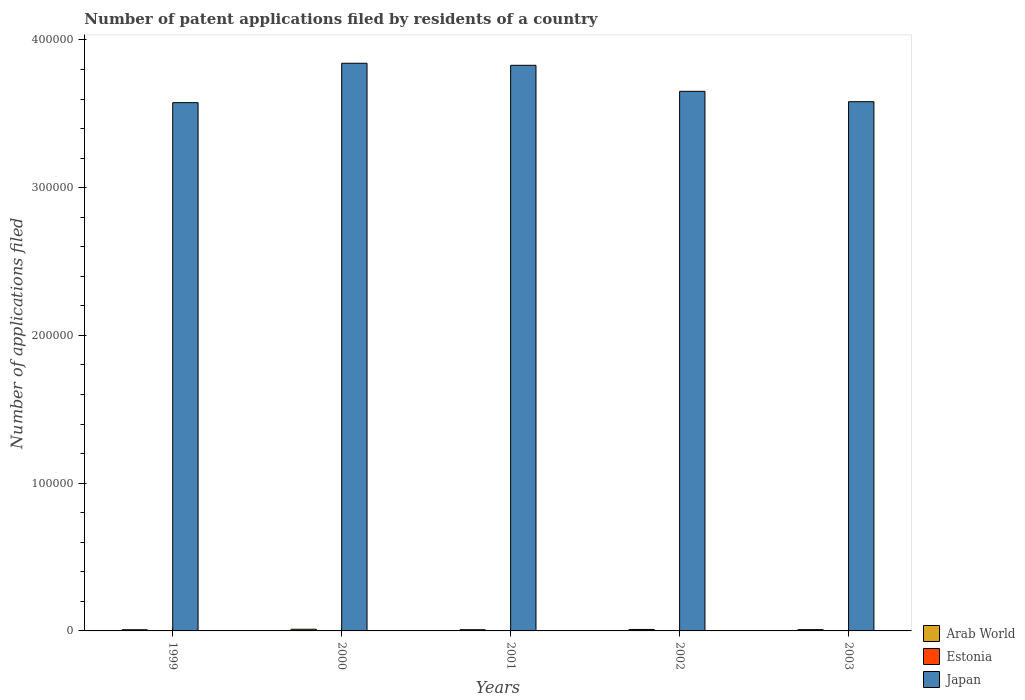How many groups of bars are there?
Your answer should be very brief. 5. Are the number of bars per tick equal to the number of legend labels?
Your response must be concise. Yes. How many bars are there on the 1st tick from the left?
Your answer should be compact. 3. How many bars are there on the 5th tick from the right?
Your answer should be very brief. 3. What is the label of the 1st group of bars from the left?
Your response must be concise. 1999. In how many cases, is the number of bars for a given year not equal to the number of legend labels?
Make the answer very short. 0. What is the number of applications filed in Estonia in 2001?
Provide a succinct answer. 18. Across all years, what is the maximum number of applications filed in Japan?
Your response must be concise. 3.84e+05. In which year was the number of applications filed in Arab World maximum?
Offer a terse response. 2000. In which year was the number of applications filed in Japan minimum?
Keep it short and to the point. 1999. What is the total number of applications filed in Japan in the graph?
Your response must be concise. 1.85e+06. What is the difference between the number of applications filed in Arab World in 1999 and that in 2002?
Provide a short and direct response. -182. What is the difference between the number of applications filed in Arab World in 2002 and the number of applications filed in Estonia in 1999?
Your answer should be compact. 978. What is the average number of applications filed in Japan per year?
Provide a short and direct response. 3.70e+05. In the year 2003, what is the difference between the number of applications filed in Arab World and number of applications filed in Estonia?
Keep it short and to the point. 856. In how many years, is the number of applications filed in Japan greater than 200000?
Offer a very short reply. 5. What is the ratio of the number of applications filed in Estonia in 2000 to that in 2002?
Offer a terse response. 0.68. What is the difference between the highest and the second highest number of applications filed in Japan?
Keep it short and to the point. 1386. What is the difference between the highest and the lowest number of applications filed in Arab World?
Provide a short and direct response. 315. In how many years, is the number of applications filed in Japan greater than the average number of applications filed in Japan taken over all years?
Offer a terse response. 2. Is the sum of the number of applications filed in Arab World in 1999 and 2001 greater than the maximum number of applications filed in Estonia across all years?
Provide a succinct answer. Yes. What does the 1st bar from the left in 2002 represents?
Provide a succinct answer. Arab World. What does the 1st bar from the right in 2000 represents?
Offer a very short reply. Japan. Is it the case that in every year, the sum of the number of applications filed in Estonia and number of applications filed in Arab World is greater than the number of applications filed in Japan?
Make the answer very short. No. Are all the bars in the graph horizontal?
Make the answer very short. No. How many years are there in the graph?
Your response must be concise. 5. Are the values on the major ticks of Y-axis written in scientific E-notation?
Offer a very short reply. No. Does the graph contain any zero values?
Offer a terse response. No. Does the graph contain grids?
Provide a succinct answer. No. Where does the legend appear in the graph?
Offer a terse response. Bottom right. What is the title of the graph?
Offer a terse response. Number of patent applications filed by residents of a country. Does "United States" appear as one of the legend labels in the graph?
Your response must be concise. No. What is the label or title of the X-axis?
Ensure brevity in your answer.  Years. What is the label or title of the Y-axis?
Offer a terse response. Number of applications filed. What is the Number of applications filed in Arab World in 1999?
Offer a very short reply. 809. What is the Number of applications filed in Japan in 1999?
Make the answer very short. 3.58e+05. What is the Number of applications filed in Arab World in 2000?
Your answer should be very brief. 1124. What is the Number of applications filed in Japan in 2000?
Offer a very short reply. 3.84e+05. What is the Number of applications filed in Arab World in 2001?
Make the answer very short. 831. What is the Number of applications filed in Japan in 2001?
Offer a very short reply. 3.83e+05. What is the Number of applications filed of Arab World in 2002?
Give a very brief answer. 991. What is the Number of applications filed in Estonia in 2002?
Make the answer very short. 19. What is the Number of applications filed of Japan in 2002?
Offer a very short reply. 3.65e+05. What is the Number of applications filed in Arab World in 2003?
Ensure brevity in your answer.  874. What is the Number of applications filed in Estonia in 2003?
Your answer should be compact. 18. What is the Number of applications filed in Japan in 2003?
Offer a terse response. 3.58e+05. Across all years, what is the maximum Number of applications filed in Arab World?
Your answer should be compact. 1124. Across all years, what is the maximum Number of applications filed in Japan?
Ensure brevity in your answer.  3.84e+05. Across all years, what is the minimum Number of applications filed in Arab World?
Ensure brevity in your answer.  809. Across all years, what is the minimum Number of applications filed of Japan?
Ensure brevity in your answer.  3.58e+05. What is the total Number of applications filed of Arab World in the graph?
Give a very brief answer. 4629. What is the total Number of applications filed in Japan in the graph?
Provide a succinct answer. 1.85e+06. What is the difference between the Number of applications filed of Arab World in 1999 and that in 2000?
Give a very brief answer. -315. What is the difference between the Number of applications filed of Estonia in 1999 and that in 2000?
Provide a short and direct response. 0. What is the difference between the Number of applications filed of Japan in 1999 and that in 2000?
Keep it short and to the point. -2.67e+04. What is the difference between the Number of applications filed of Arab World in 1999 and that in 2001?
Offer a terse response. -22. What is the difference between the Number of applications filed of Japan in 1999 and that in 2001?
Keep it short and to the point. -2.53e+04. What is the difference between the Number of applications filed of Arab World in 1999 and that in 2002?
Your response must be concise. -182. What is the difference between the Number of applications filed of Japan in 1999 and that in 2002?
Provide a succinct answer. -7673. What is the difference between the Number of applications filed in Arab World in 1999 and that in 2003?
Offer a terse response. -65. What is the difference between the Number of applications filed of Japan in 1999 and that in 2003?
Provide a succinct answer. -653. What is the difference between the Number of applications filed in Arab World in 2000 and that in 2001?
Your response must be concise. 293. What is the difference between the Number of applications filed of Japan in 2000 and that in 2001?
Offer a terse response. 1386. What is the difference between the Number of applications filed of Arab World in 2000 and that in 2002?
Your answer should be very brief. 133. What is the difference between the Number of applications filed in Estonia in 2000 and that in 2002?
Offer a terse response. -6. What is the difference between the Number of applications filed in Japan in 2000 and that in 2002?
Your response must be concise. 1.90e+04. What is the difference between the Number of applications filed of Arab World in 2000 and that in 2003?
Ensure brevity in your answer.  250. What is the difference between the Number of applications filed in Japan in 2000 and that in 2003?
Provide a succinct answer. 2.60e+04. What is the difference between the Number of applications filed in Arab World in 2001 and that in 2002?
Keep it short and to the point. -160. What is the difference between the Number of applications filed in Japan in 2001 and that in 2002?
Provide a succinct answer. 1.76e+04. What is the difference between the Number of applications filed in Arab World in 2001 and that in 2003?
Offer a terse response. -43. What is the difference between the Number of applications filed of Japan in 2001 and that in 2003?
Your response must be concise. 2.46e+04. What is the difference between the Number of applications filed of Arab World in 2002 and that in 2003?
Make the answer very short. 117. What is the difference between the Number of applications filed of Japan in 2002 and that in 2003?
Your response must be concise. 7020. What is the difference between the Number of applications filed in Arab World in 1999 and the Number of applications filed in Estonia in 2000?
Provide a short and direct response. 796. What is the difference between the Number of applications filed of Arab World in 1999 and the Number of applications filed of Japan in 2000?
Provide a succinct answer. -3.83e+05. What is the difference between the Number of applications filed of Estonia in 1999 and the Number of applications filed of Japan in 2000?
Keep it short and to the point. -3.84e+05. What is the difference between the Number of applications filed in Arab World in 1999 and the Number of applications filed in Estonia in 2001?
Keep it short and to the point. 791. What is the difference between the Number of applications filed in Arab World in 1999 and the Number of applications filed in Japan in 2001?
Provide a short and direct response. -3.82e+05. What is the difference between the Number of applications filed in Estonia in 1999 and the Number of applications filed in Japan in 2001?
Give a very brief answer. -3.83e+05. What is the difference between the Number of applications filed in Arab World in 1999 and the Number of applications filed in Estonia in 2002?
Offer a terse response. 790. What is the difference between the Number of applications filed in Arab World in 1999 and the Number of applications filed in Japan in 2002?
Your answer should be compact. -3.64e+05. What is the difference between the Number of applications filed of Estonia in 1999 and the Number of applications filed of Japan in 2002?
Offer a terse response. -3.65e+05. What is the difference between the Number of applications filed in Arab World in 1999 and the Number of applications filed in Estonia in 2003?
Make the answer very short. 791. What is the difference between the Number of applications filed in Arab World in 1999 and the Number of applications filed in Japan in 2003?
Make the answer very short. -3.57e+05. What is the difference between the Number of applications filed of Estonia in 1999 and the Number of applications filed of Japan in 2003?
Give a very brief answer. -3.58e+05. What is the difference between the Number of applications filed of Arab World in 2000 and the Number of applications filed of Estonia in 2001?
Your response must be concise. 1106. What is the difference between the Number of applications filed in Arab World in 2000 and the Number of applications filed in Japan in 2001?
Offer a very short reply. -3.82e+05. What is the difference between the Number of applications filed of Estonia in 2000 and the Number of applications filed of Japan in 2001?
Your answer should be very brief. -3.83e+05. What is the difference between the Number of applications filed in Arab World in 2000 and the Number of applications filed in Estonia in 2002?
Offer a very short reply. 1105. What is the difference between the Number of applications filed in Arab World in 2000 and the Number of applications filed in Japan in 2002?
Ensure brevity in your answer.  -3.64e+05. What is the difference between the Number of applications filed of Estonia in 2000 and the Number of applications filed of Japan in 2002?
Your response must be concise. -3.65e+05. What is the difference between the Number of applications filed in Arab World in 2000 and the Number of applications filed in Estonia in 2003?
Your answer should be very brief. 1106. What is the difference between the Number of applications filed of Arab World in 2000 and the Number of applications filed of Japan in 2003?
Keep it short and to the point. -3.57e+05. What is the difference between the Number of applications filed of Estonia in 2000 and the Number of applications filed of Japan in 2003?
Offer a very short reply. -3.58e+05. What is the difference between the Number of applications filed of Arab World in 2001 and the Number of applications filed of Estonia in 2002?
Offer a very short reply. 812. What is the difference between the Number of applications filed in Arab World in 2001 and the Number of applications filed in Japan in 2002?
Give a very brief answer. -3.64e+05. What is the difference between the Number of applications filed in Estonia in 2001 and the Number of applications filed in Japan in 2002?
Make the answer very short. -3.65e+05. What is the difference between the Number of applications filed in Arab World in 2001 and the Number of applications filed in Estonia in 2003?
Provide a short and direct response. 813. What is the difference between the Number of applications filed of Arab World in 2001 and the Number of applications filed of Japan in 2003?
Keep it short and to the point. -3.57e+05. What is the difference between the Number of applications filed of Estonia in 2001 and the Number of applications filed of Japan in 2003?
Your answer should be compact. -3.58e+05. What is the difference between the Number of applications filed of Arab World in 2002 and the Number of applications filed of Estonia in 2003?
Offer a very short reply. 973. What is the difference between the Number of applications filed of Arab World in 2002 and the Number of applications filed of Japan in 2003?
Offer a terse response. -3.57e+05. What is the difference between the Number of applications filed of Estonia in 2002 and the Number of applications filed of Japan in 2003?
Your response must be concise. -3.58e+05. What is the average Number of applications filed of Arab World per year?
Provide a short and direct response. 925.8. What is the average Number of applications filed in Japan per year?
Your answer should be compact. 3.70e+05. In the year 1999, what is the difference between the Number of applications filed in Arab World and Number of applications filed in Estonia?
Provide a succinct answer. 796. In the year 1999, what is the difference between the Number of applications filed in Arab World and Number of applications filed in Japan?
Keep it short and to the point. -3.57e+05. In the year 1999, what is the difference between the Number of applications filed in Estonia and Number of applications filed in Japan?
Your answer should be compact. -3.58e+05. In the year 2000, what is the difference between the Number of applications filed in Arab World and Number of applications filed in Estonia?
Make the answer very short. 1111. In the year 2000, what is the difference between the Number of applications filed in Arab World and Number of applications filed in Japan?
Keep it short and to the point. -3.83e+05. In the year 2000, what is the difference between the Number of applications filed in Estonia and Number of applications filed in Japan?
Ensure brevity in your answer.  -3.84e+05. In the year 2001, what is the difference between the Number of applications filed of Arab World and Number of applications filed of Estonia?
Your response must be concise. 813. In the year 2001, what is the difference between the Number of applications filed in Arab World and Number of applications filed in Japan?
Give a very brief answer. -3.82e+05. In the year 2001, what is the difference between the Number of applications filed in Estonia and Number of applications filed in Japan?
Provide a short and direct response. -3.83e+05. In the year 2002, what is the difference between the Number of applications filed of Arab World and Number of applications filed of Estonia?
Your answer should be very brief. 972. In the year 2002, what is the difference between the Number of applications filed of Arab World and Number of applications filed of Japan?
Your answer should be very brief. -3.64e+05. In the year 2002, what is the difference between the Number of applications filed in Estonia and Number of applications filed in Japan?
Keep it short and to the point. -3.65e+05. In the year 2003, what is the difference between the Number of applications filed of Arab World and Number of applications filed of Estonia?
Offer a terse response. 856. In the year 2003, what is the difference between the Number of applications filed of Arab World and Number of applications filed of Japan?
Offer a terse response. -3.57e+05. In the year 2003, what is the difference between the Number of applications filed in Estonia and Number of applications filed in Japan?
Provide a succinct answer. -3.58e+05. What is the ratio of the Number of applications filed in Arab World in 1999 to that in 2000?
Offer a very short reply. 0.72. What is the ratio of the Number of applications filed in Estonia in 1999 to that in 2000?
Your answer should be compact. 1. What is the ratio of the Number of applications filed of Japan in 1999 to that in 2000?
Keep it short and to the point. 0.93. What is the ratio of the Number of applications filed in Arab World in 1999 to that in 2001?
Ensure brevity in your answer.  0.97. What is the ratio of the Number of applications filed in Estonia in 1999 to that in 2001?
Your answer should be compact. 0.72. What is the ratio of the Number of applications filed in Japan in 1999 to that in 2001?
Your answer should be compact. 0.93. What is the ratio of the Number of applications filed in Arab World in 1999 to that in 2002?
Offer a terse response. 0.82. What is the ratio of the Number of applications filed of Estonia in 1999 to that in 2002?
Your answer should be very brief. 0.68. What is the ratio of the Number of applications filed of Japan in 1999 to that in 2002?
Make the answer very short. 0.98. What is the ratio of the Number of applications filed of Arab World in 1999 to that in 2003?
Provide a succinct answer. 0.93. What is the ratio of the Number of applications filed in Estonia in 1999 to that in 2003?
Your answer should be very brief. 0.72. What is the ratio of the Number of applications filed in Japan in 1999 to that in 2003?
Keep it short and to the point. 1. What is the ratio of the Number of applications filed in Arab World in 2000 to that in 2001?
Give a very brief answer. 1.35. What is the ratio of the Number of applications filed in Estonia in 2000 to that in 2001?
Provide a succinct answer. 0.72. What is the ratio of the Number of applications filed of Japan in 2000 to that in 2001?
Give a very brief answer. 1. What is the ratio of the Number of applications filed of Arab World in 2000 to that in 2002?
Your answer should be very brief. 1.13. What is the ratio of the Number of applications filed of Estonia in 2000 to that in 2002?
Keep it short and to the point. 0.68. What is the ratio of the Number of applications filed of Japan in 2000 to that in 2002?
Offer a terse response. 1.05. What is the ratio of the Number of applications filed of Arab World in 2000 to that in 2003?
Ensure brevity in your answer.  1.29. What is the ratio of the Number of applications filed of Estonia in 2000 to that in 2003?
Provide a succinct answer. 0.72. What is the ratio of the Number of applications filed in Japan in 2000 to that in 2003?
Keep it short and to the point. 1.07. What is the ratio of the Number of applications filed of Arab World in 2001 to that in 2002?
Provide a succinct answer. 0.84. What is the ratio of the Number of applications filed in Japan in 2001 to that in 2002?
Keep it short and to the point. 1.05. What is the ratio of the Number of applications filed in Arab World in 2001 to that in 2003?
Offer a very short reply. 0.95. What is the ratio of the Number of applications filed of Estonia in 2001 to that in 2003?
Provide a succinct answer. 1. What is the ratio of the Number of applications filed in Japan in 2001 to that in 2003?
Offer a very short reply. 1.07. What is the ratio of the Number of applications filed in Arab World in 2002 to that in 2003?
Give a very brief answer. 1.13. What is the ratio of the Number of applications filed of Estonia in 2002 to that in 2003?
Provide a succinct answer. 1.06. What is the ratio of the Number of applications filed in Japan in 2002 to that in 2003?
Your response must be concise. 1.02. What is the difference between the highest and the second highest Number of applications filed in Arab World?
Ensure brevity in your answer.  133. What is the difference between the highest and the second highest Number of applications filed of Japan?
Your answer should be compact. 1386. What is the difference between the highest and the lowest Number of applications filed of Arab World?
Your response must be concise. 315. What is the difference between the highest and the lowest Number of applications filed in Japan?
Your response must be concise. 2.67e+04. 